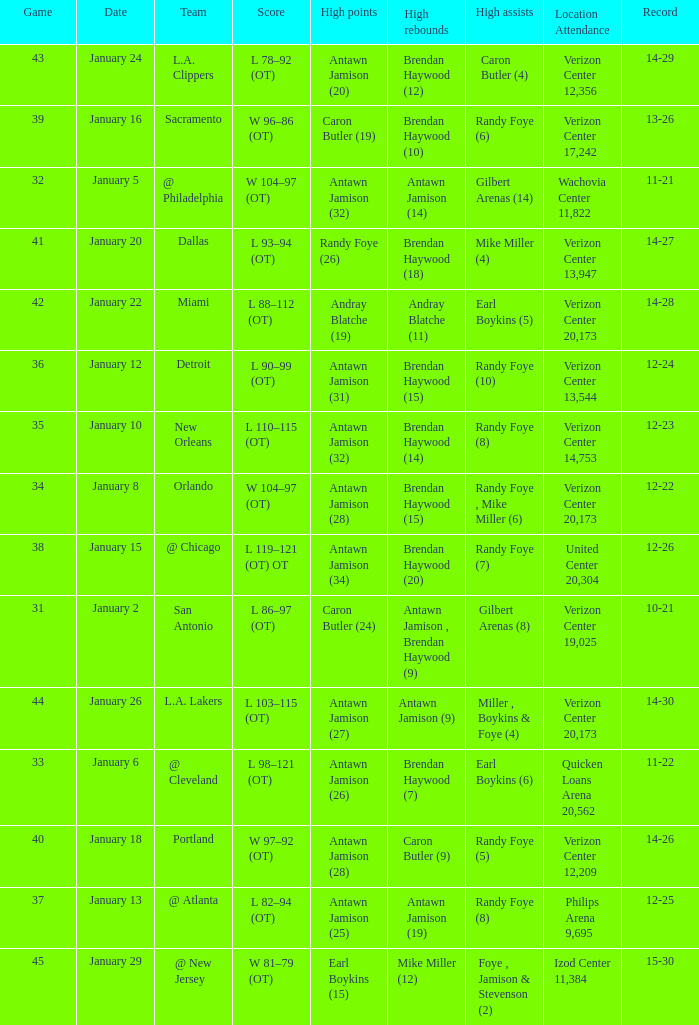Who had the highest points on January 2? Caron Butler (24). 